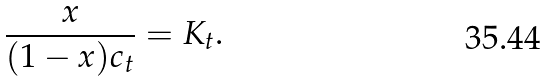<formula> <loc_0><loc_0><loc_500><loc_500>\frac { x } { ( 1 - x ) c _ { t } } = K _ { t } .</formula> 